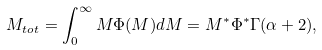<formula> <loc_0><loc_0><loc_500><loc_500>M _ { t o t } = \int _ { 0 } ^ { \infty } M \Phi ( M ) d M = M ^ { \ast } \Phi ^ { \ast } \Gamma ( \alpha + 2 ) ,</formula> 